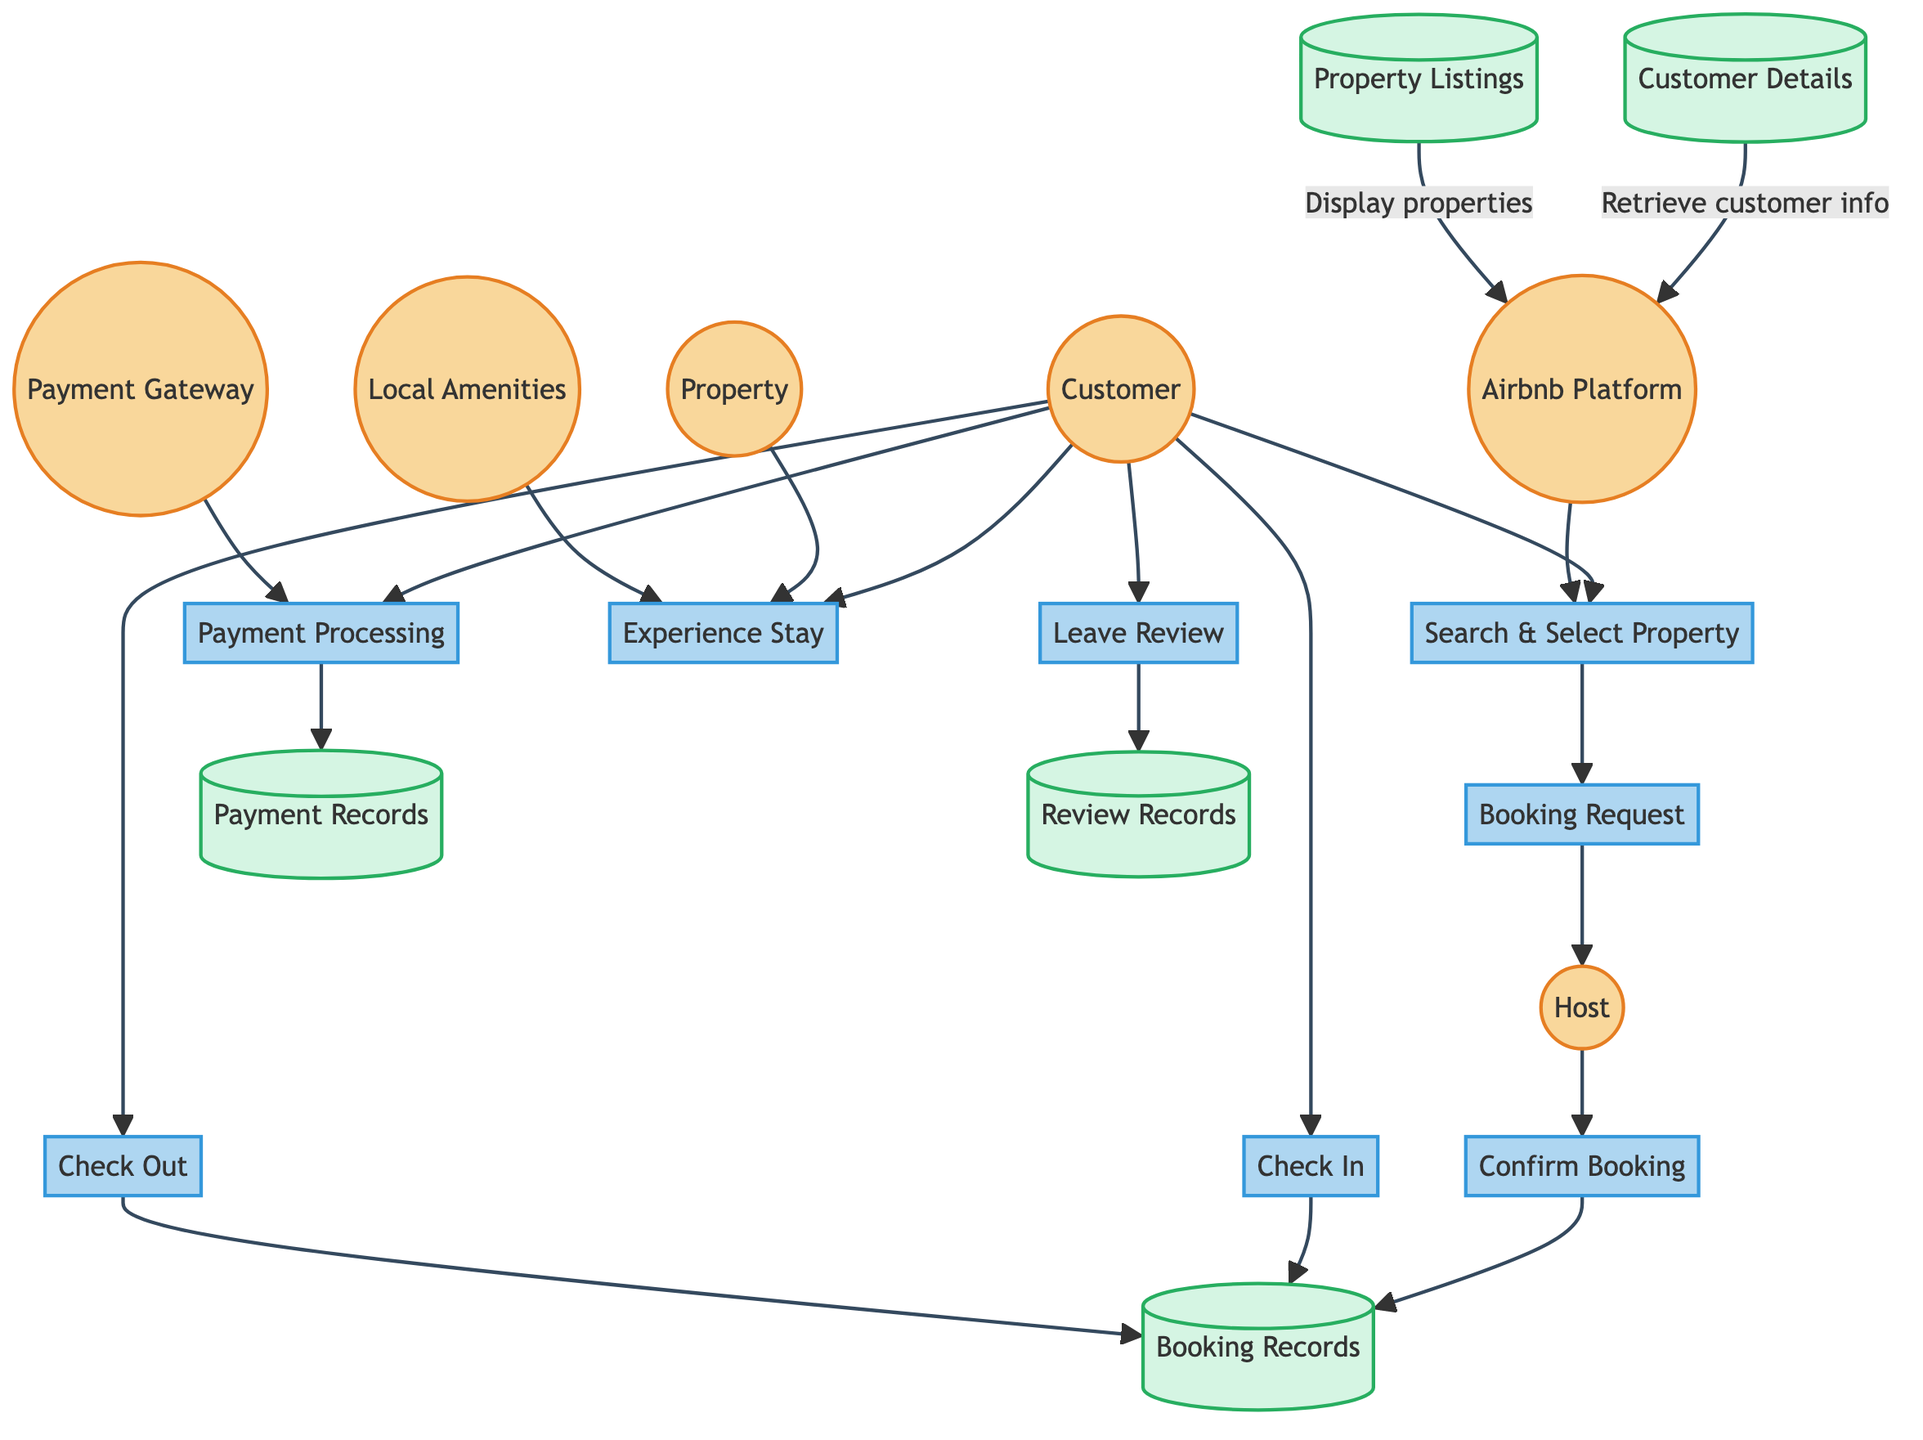What is the first process in the customer journey? The first process shown in the diagram is "Search & Select Property," which is focused on the customer's initial interaction when searching for rental properties.
Answer: Search & Select Property How many entities are represented in the diagram? The diagram features six entities: Customer, Airbnb Platform, Host, Property, Payment Gateway, and Local Amenities. By counting each entity node without repetitions, we find a total of six.
Answer: 6 What is the output of the "BookingRequest" process? The output from the "BookingRequest" process is "BookingRequest," which signifies that a booking request has been created after the customer selects a property.
Answer: BookingRequest Which process requires customer input before any other? The process "Search & Select Property" requires input from the customer to initiate their search for rental properties, thus making it the first point of engagement.
Answer: Search & Select Property What connects the "CheckIn" notification to the "BookingRecords" data store? The "CheckIn" process outputs a "CheckInNotification," which flows into the "BookingRecords" data store to update the status of the booking.
Answer: CheckInNotification How does the "PaymentProcessing" process interact with the "PaymentGateway"? The "PaymentProcessing" process involves the "PaymentGateway" as a requirement to process the customer's payment and is dependent on it to complete the transaction.
Answer: PaymentGateway What is the final process a customer engages in before exiting the journey? The final process before exiting the customer journey is "Leave Review," which follows after the customer has experienced their stay.
Answer: Leave Review What type of data is stored in the "ReviewRecords" data store? The "ReviewRecords" data store holds all "Customer Review" outputs created when customers leave feedback about their stay, incorporating ratings and comments.
Answer: Customer Review How many data flows are present in the diagram? The diagram shows eight data flows that represent the movement of data between processes and data stores throughout the customer journey.
Answer: 8 